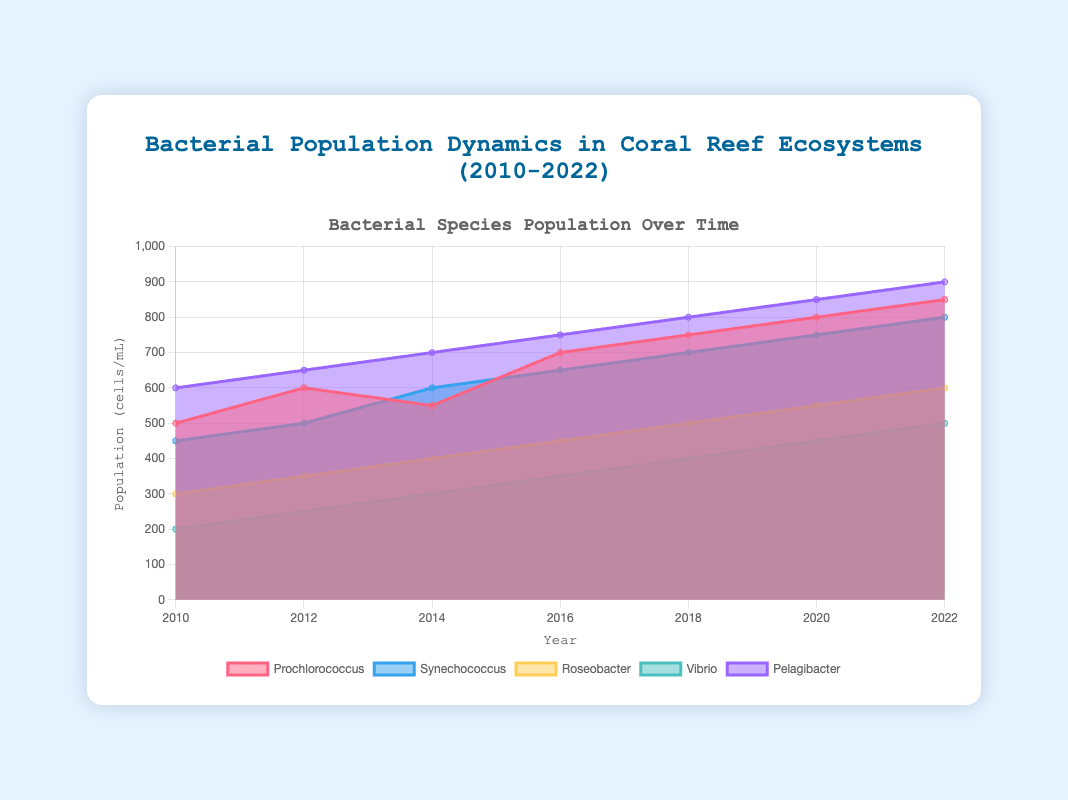What is the title of the chart? The title of the chart is displayed at the top center of the figure and reads "Bacterial Population Dynamics in Coral Reef Ecosystems (2010-2022)".
Answer: Bacterial Population Dynamics in Coral Reef Ecosystems (2010-2022) Which bacterial species had the highest population in 2010? Looking at the data points for the year 2010, the bacterial species with the highest population value is Pelagibacter with 600 cells/mL.
Answer: Pelagibacter What is the color of the area representing Synechococcus? The color used for Synechococcus is visible in the legend and within the chart. It is represented by a blue-like color (rgba with the values 54, 162, 235).
Answer: Blue By how much did the population of Vibrio increase from 2010 to 2022? The population of Vibrio in 2010 was 200 cells/mL and in 2022 it was 500 cells/mL. To find the increase, subtract the earlier value from the later value: 500 - 200 = 300.
Answer: 300 Which bacterial species showed the least growth from 2010 to 2022? To find the species with the least growth, calculate the difference between the population values in 2022 and 2010 for each species. Prochlorococcus (850-500=350), Synechococcus (800-450=350), Roseobacter (600-300=300), Vibrio (500-200=300), Pelagibacter (900-600=300). Therefore, Roseobacter, Vibrio, and Pelagibacter showed equal least growth of 300 cells/mL.
Answer: Roseobacter, Vibrio, Pelagibacter What is the average population of Prochlorococcus over the years? The populations of Prochlorococcus from 2010 to 2022 are [500, 600, 550, 700, 750, 800, 850]. Adding these values gives 4750, and dividing by the number of years (7) gives 4750/7 ≈ 678.57.
Answer: 678.57 Did any bacterial species have a consistent increase in population across all time periods? Which are they? By examining the population data for each species across the years, it is observed that all bacterial species (Prochlorococcus, Synechococcus, Roseobacter, Vibrio, and Pelagibacter) show increasing trends in their populations over the given time periods.
Answer: All species Which bacterial species has the steepest increase in population between any two consecutive years? Calculate the differences in population between consecutive years for each species and find the maximum increase. The steepest increase occurs for Prochlorococcus between 2012 and 2014 (700 - 600 = 100).
Answer: Prochlorococcus (2012-2014) How does the population of Roseobacter in 2014 compare to that of Synechococcus in 2010? The population values are 400 cells/mL for Roseobacter in 2014 and 450 cells/mL for Synechococcus in 2010. Therefore, the population of Roseobacter in 2014 is 50 cells/mL less than that of Synechococcus in 2010.
Answer: 50 less 